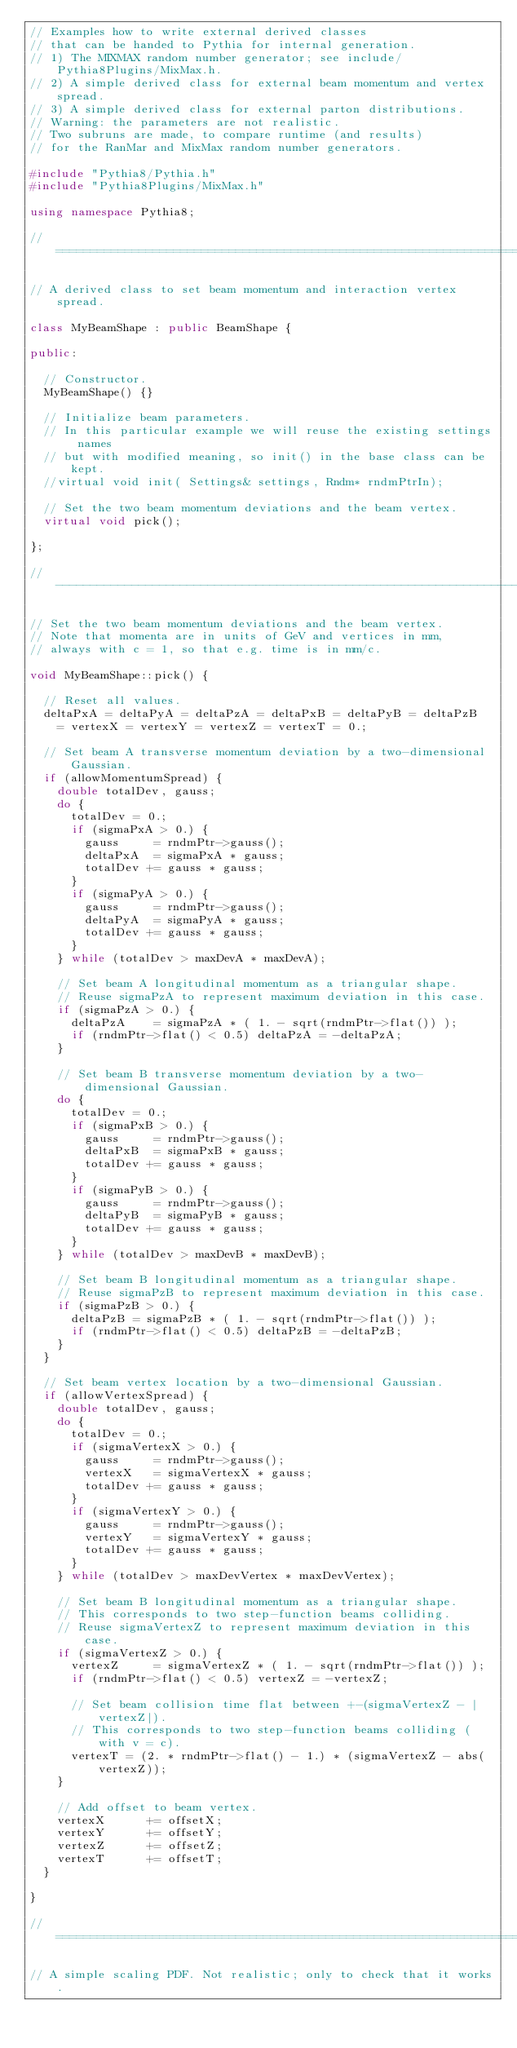<code> <loc_0><loc_0><loc_500><loc_500><_C++_>// Examples how to write external derived classes
// that can be handed to Pythia for internal generation.
// 1) The MIXMAX random number generator; see include/Pythia8Plugins/MixMax.h.
// 2) A simple derived class for external beam momentum and vertex spread.
// 3) A simple derived class for external parton distributions.
// Warning: the parameters are not realistic.
// Two subruns are made, to compare runtime (and results)
// for the RanMar and MixMax random number generators.

#include "Pythia8/Pythia.h"
#include "Pythia8Plugins/MixMax.h"

using namespace Pythia8;

//==========================================================================

// A derived class to set beam momentum and interaction vertex spread.

class MyBeamShape : public BeamShape {

public:

  // Constructor.
  MyBeamShape() {}

  // Initialize beam parameters.
  // In this particular example we will reuse the existing settings names
  // but with modified meaning, so init() in the base class can be kept.
  //virtual void init( Settings& settings, Rndm* rndmPtrIn);

  // Set the two beam momentum deviations and the beam vertex.
  virtual void pick();

};

//--------------------------------------------------------------------------

// Set the two beam momentum deviations and the beam vertex.
// Note that momenta are in units of GeV and vertices in mm,
// always with c = 1, so that e.g. time is in mm/c.

void MyBeamShape::pick() {

  // Reset all values.
  deltaPxA = deltaPyA = deltaPzA = deltaPxB = deltaPyB = deltaPzB
    = vertexX = vertexY = vertexZ = vertexT = 0.;

  // Set beam A transverse momentum deviation by a two-dimensional Gaussian.
  if (allowMomentumSpread) {
    double totalDev, gauss;
    do {
      totalDev = 0.;
      if (sigmaPxA > 0.) {
        gauss     = rndmPtr->gauss();
        deltaPxA  = sigmaPxA * gauss;
        totalDev += gauss * gauss;
      }
      if (sigmaPyA > 0.) {
        gauss     = rndmPtr->gauss();
        deltaPyA  = sigmaPyA * gauss;
        totalDev += gauss * gauss;
      }
    } while (totalDev > maxDevA * maxDevA);

    // Set beam A longitudinal momentum as a triangular shape.
    // Reuse sigmaPzA to represent maximum deviation in this case.
    if (sigmaPzA > 0.) {
      deltaPzA    = sigmaPzA * ( 1. - sqrt(rndmPtr->flat()) );
      if (rndmPtr->flat() < 0.5) deltaPzA = -deltaPzA;
    }

    // Set beam B transverse momentum deviation by a two-dimensional Gaussian.
    do {
      totalDev = 0.;
      if (sigmaPxB > 0.) {
        gauss     = rndmPtr->gauss();
        deltaPxB  = sigmaPxB * gauss;
        totalDev += gauss * gauss;
      }
      if (sigmaPyB > 0.) {
        gauss     = rndmPtr->gauss();
        deltaPyB  = sigmaPyB * gauss;
        totalDev += gauss * gauss;
      }
    } while (totalDev > maxDevB * maxDevB);

    // Set beam B longitudinal momentum as a triangular shape.
    // Reuse sigmaPzB to represent maximum deviation in this case.
    if (sigmaPzB > 0.) {
      deltaPzB = sigmaPzB * ( 1. - sqrt(rndmPtr->flat()) );
      if (rndmPtr->flat() < 0.5) deltaPzB = -deltaPzB;
    }
  }

  // Set beam vertex location by a two-dimensional Gaussian.
  if (allowVertexSpread) {
    double totalDev, gauss;
    do {
      totalDev = 0.;
      if (sigmaVertexX > 0.) {
        gauss     = rndmPtr->gauss();
        vertexX   = sigmaVertexX * gauss;
        totalDev += gauss * gauss;
      }
      if (sigmaVertexY > 0.) {
        gauss     = rndmPtr->gauss();
        vertexY   = sigmaVertexY * gauss;
        totalDev += gauss * gauss;
      }
    } while (totalDev > maxDevVertex * maxDevVertex);

    // Set beam B longitudinal momentum as a triangular shape.
    // This corresponds to two step-function beams colliding.
    // Reuse sigmaVertexZ to represent maximum deviation in this case.
    if (sigmaVertexZ > 0.) {
      vertexZ     = sigmaVertexZ * ( 1. - sqrt(rndmPtr->flat()) );
      if (rndmPtr->flat() < 0.5) vertexZ = -vertexZ;

      // Set beam collision time flat between +-(sigmaVertexZ - |vertexZ|).
      // This corresponds to two step-function beams colliding (with v = c).
      vertexT = (2. * rndmPtr->flat() - 1.) * (sigmaVertexZ - abs(vertexZ));
    }

    // Add offset to beam vertex.
    vertexX      += offsetX;
    vertexY      += offsetY;
    vertexZ      += offsetZ;
    vertexT      += offsetT;
  }

}

//==========================================================================

// A simple scaling PDF. Not realistic; only to check that it works.
</code> 